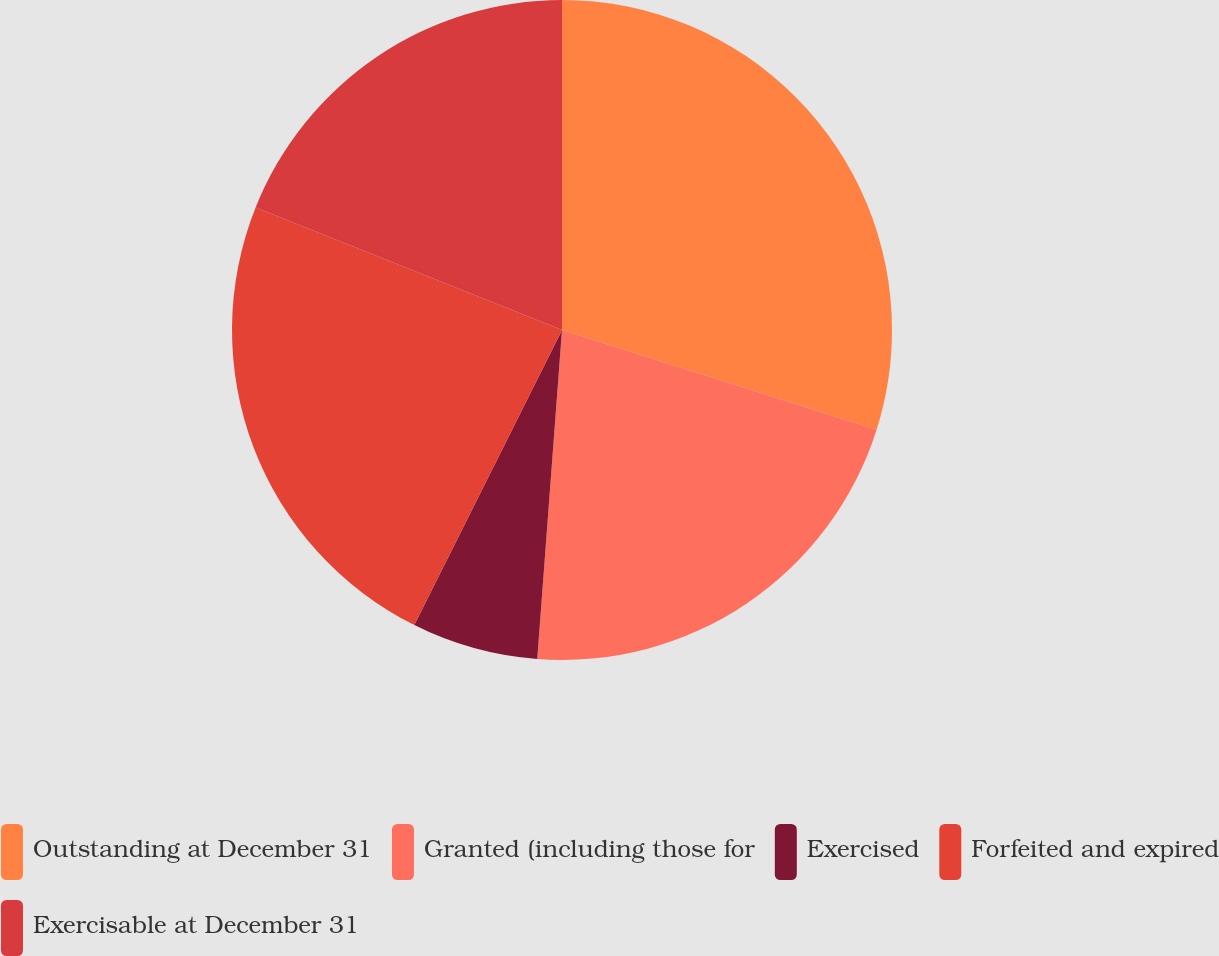Convert chart. <chart><loc_0><loc_0><loc_500><loc_500><pie_chart><fcel>Outstanding at December 31<fcel>Granted (including those for<fcel>Exercised<fcel>Forfeited and expired<fcel>Exercisable at December 31<nl><fcel>29.88%<fcel>21.31%<fcel>6.19%<fcel>23.67%<fcel>18.94%<nl></chart> 